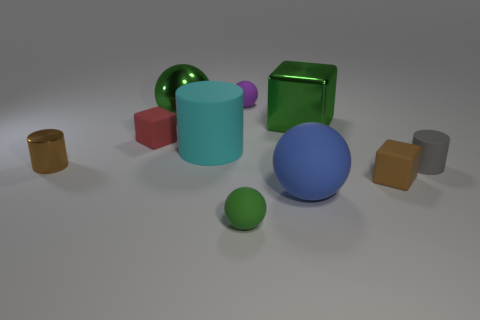Are there more big things than large cyan metallic cubes?
Your answer should be very brief. Yes. Are any tiny green matte objects visible?
Your answer should be very brief. Yes. How many objects are small brown objects that are left of the cyan rubber object or objects in front of the small gray matte cylinder?
Ensure brevity in your answer.  4. Do the big shiny sphere and the big block have the same color?
Your response must be concise. Yes. Is the number of tiny gray objects less than the number of tiny green metal cylinders?
Keep it short and to the point. No. Are there any matte cylinders left of the large green block?
Ensure brevity in your answer.  Yes. Is the purple object made of the same material as the red block?
Provide a short and direct response. Yes. There is another small matte thing that is the same shape as the cyan rubber thing; what color is it?
Make the answer very short. Gray. There is a metal object on the right side of the purple matte thing; does it have the same color as the shiny ball?
Provide a short and direct response. Yes. The shiny thing that is the same color as the metallic ball is what shape?
Provide a short and direct response. Cube. 